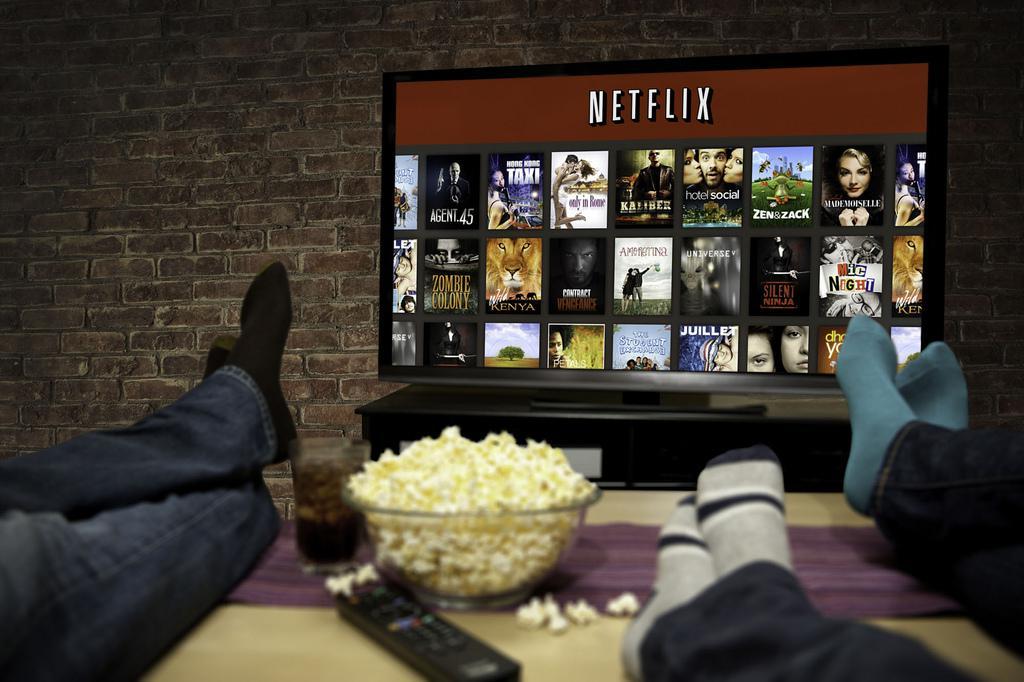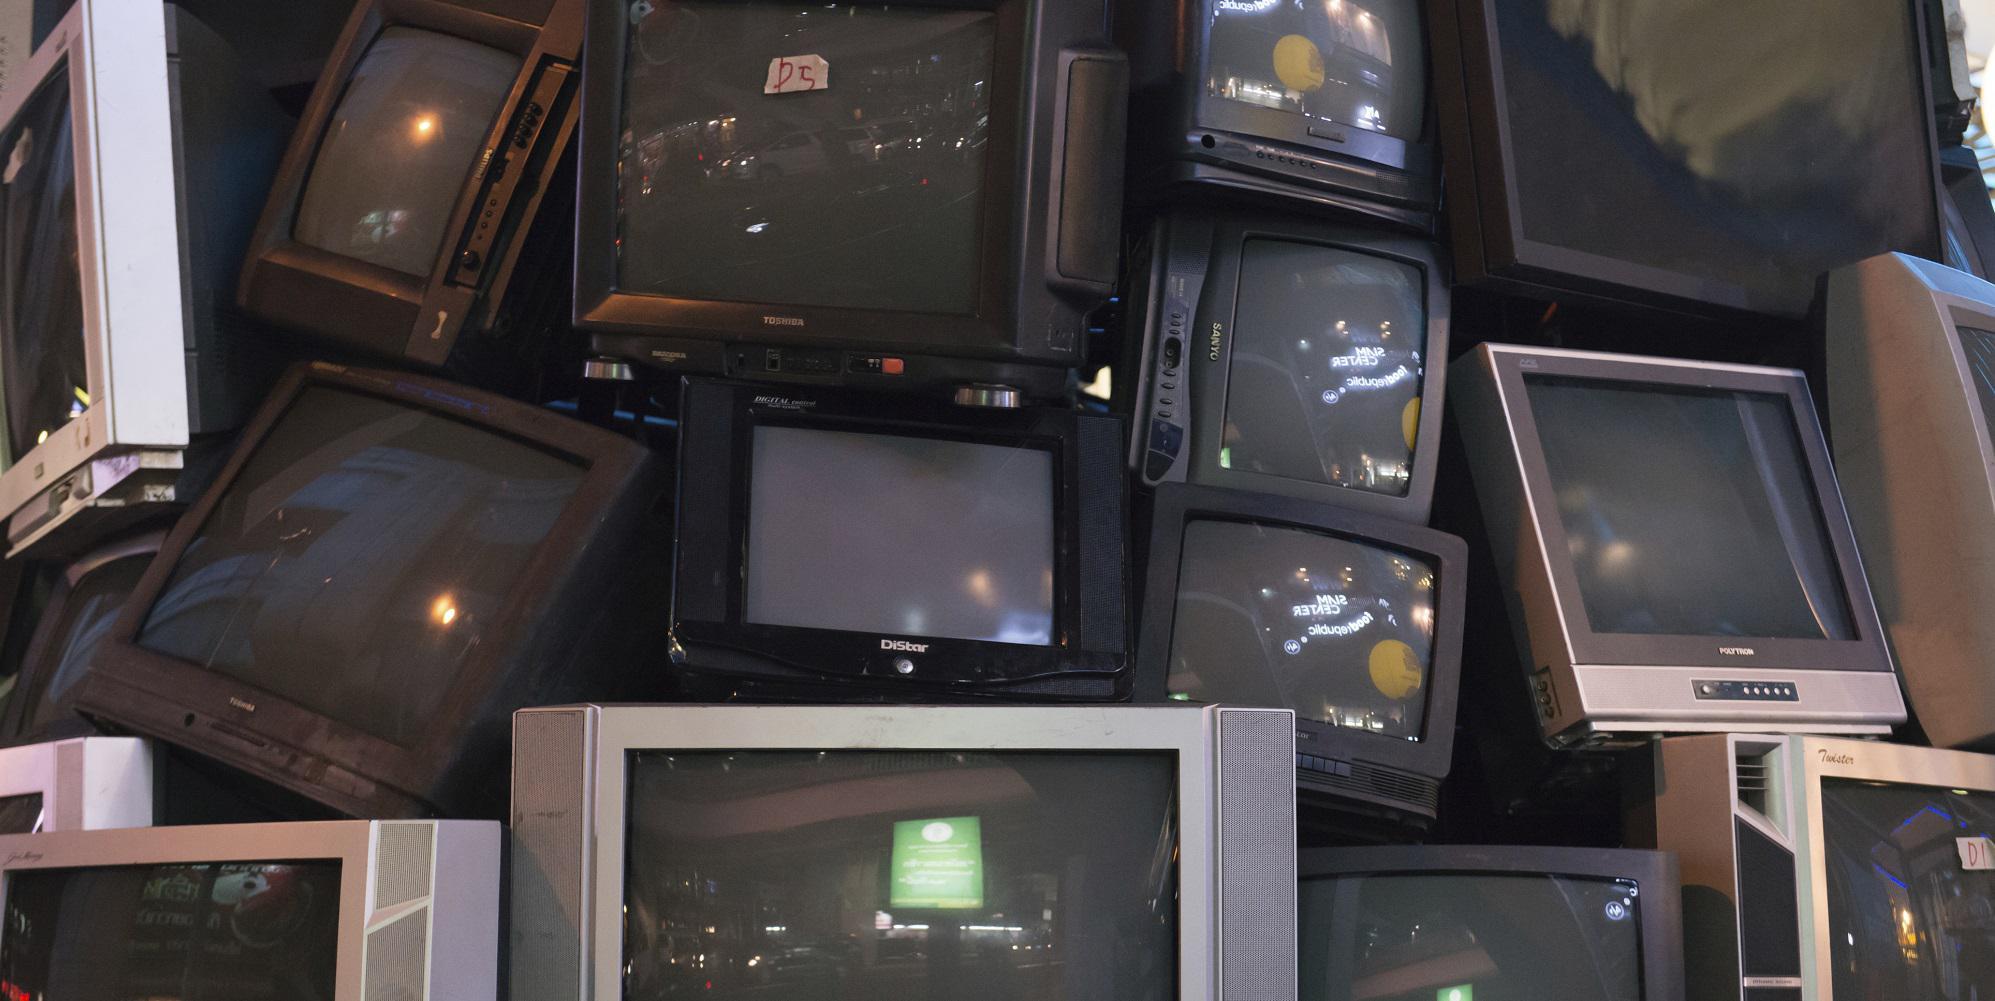The first image is the image on the left, the second image is the image on the right. Considering the images on both sides, is "In at least one image, one or more overhead televisions are playing in a restaurant." valid? Answer yes or no. No. 